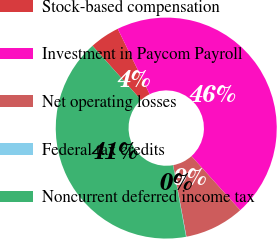Convert chart. <chart><loc_0><loc_0><loc_500><loc_500><pie_chart><fcel>Stock-based compensation<fcel>Investment in Paycom Payroll<fcel>Net operating losses<fcel>Federal tax credits<fcel>Noncurrent deferred income tax<nl><fcel>4.4%<fcel>45.57%<fcel>8.74%<fcel>0.06%<fcel>41.23%<nl></chart> 